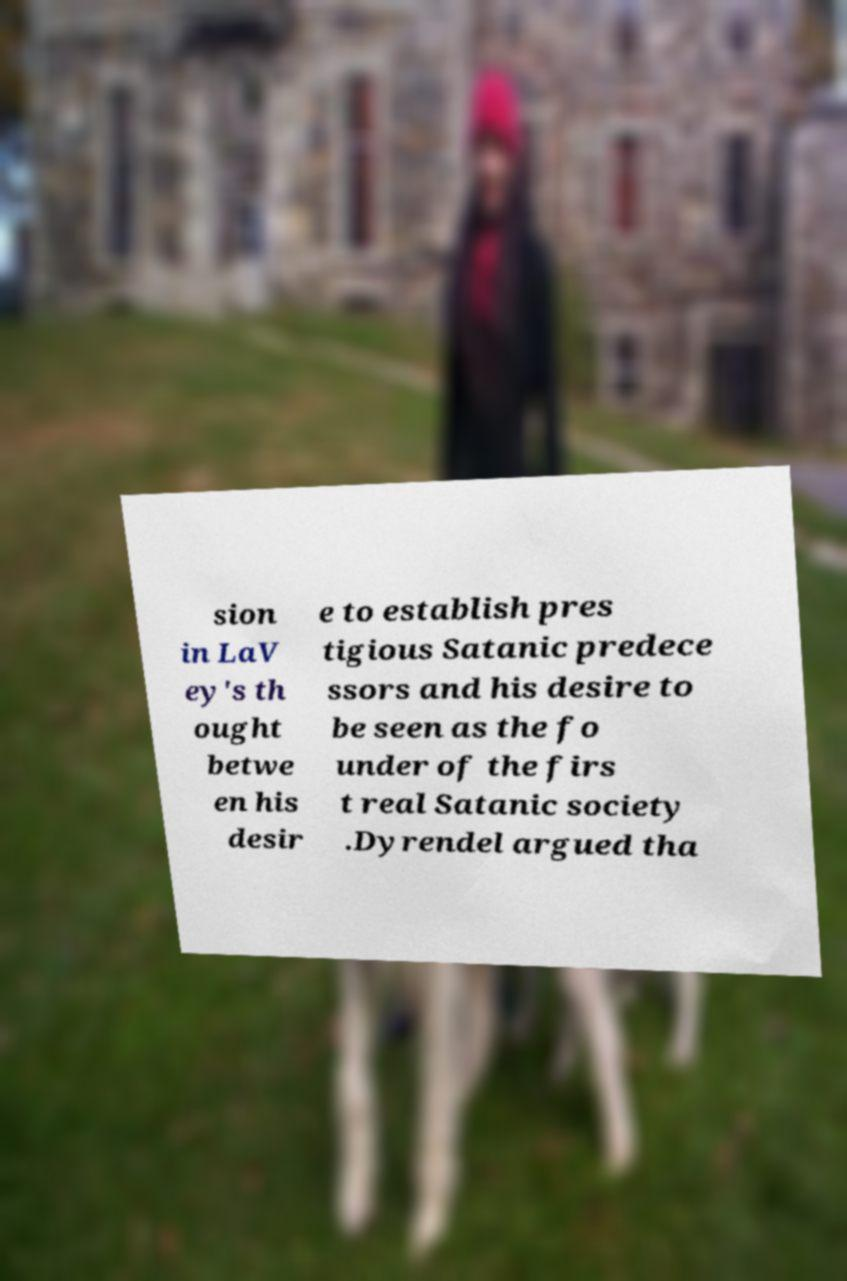I need the written content from this picture converted into text. Can you do that? sion in LaV ey's th ought betwe en his desir e to establish pres tigious Satanic predece ssors and his desire to be seen as the fo under of the firs t real Satanic society .Dyrendel argued tha 